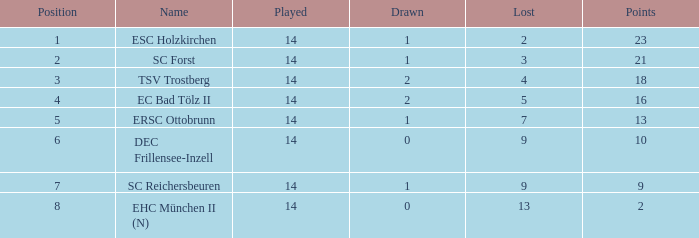Which Points have a Position larger than 6, and a Lost smaller than 13? 9.0. 